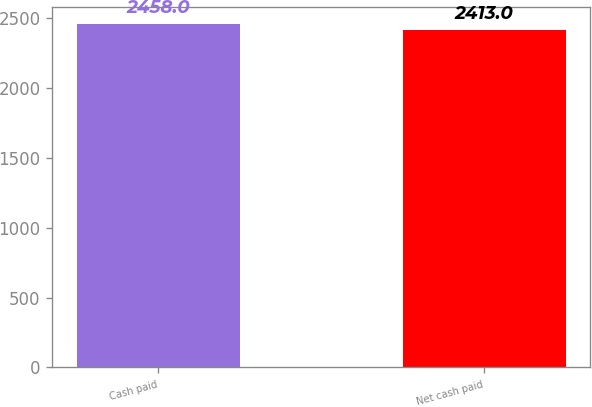Convert chart. <chart><loc_0><loc_0><loc_500><loc_500><bar_chart><fcel>Cash paid<fcel>Net cash paid<nl><fcel>2458<fcel>2413<nl></chart> 